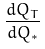<formula> <loc_0><loc_0><loc_500><loc_500>\frac { d Q _ { T } } { d Q _ { * } }</formula> 